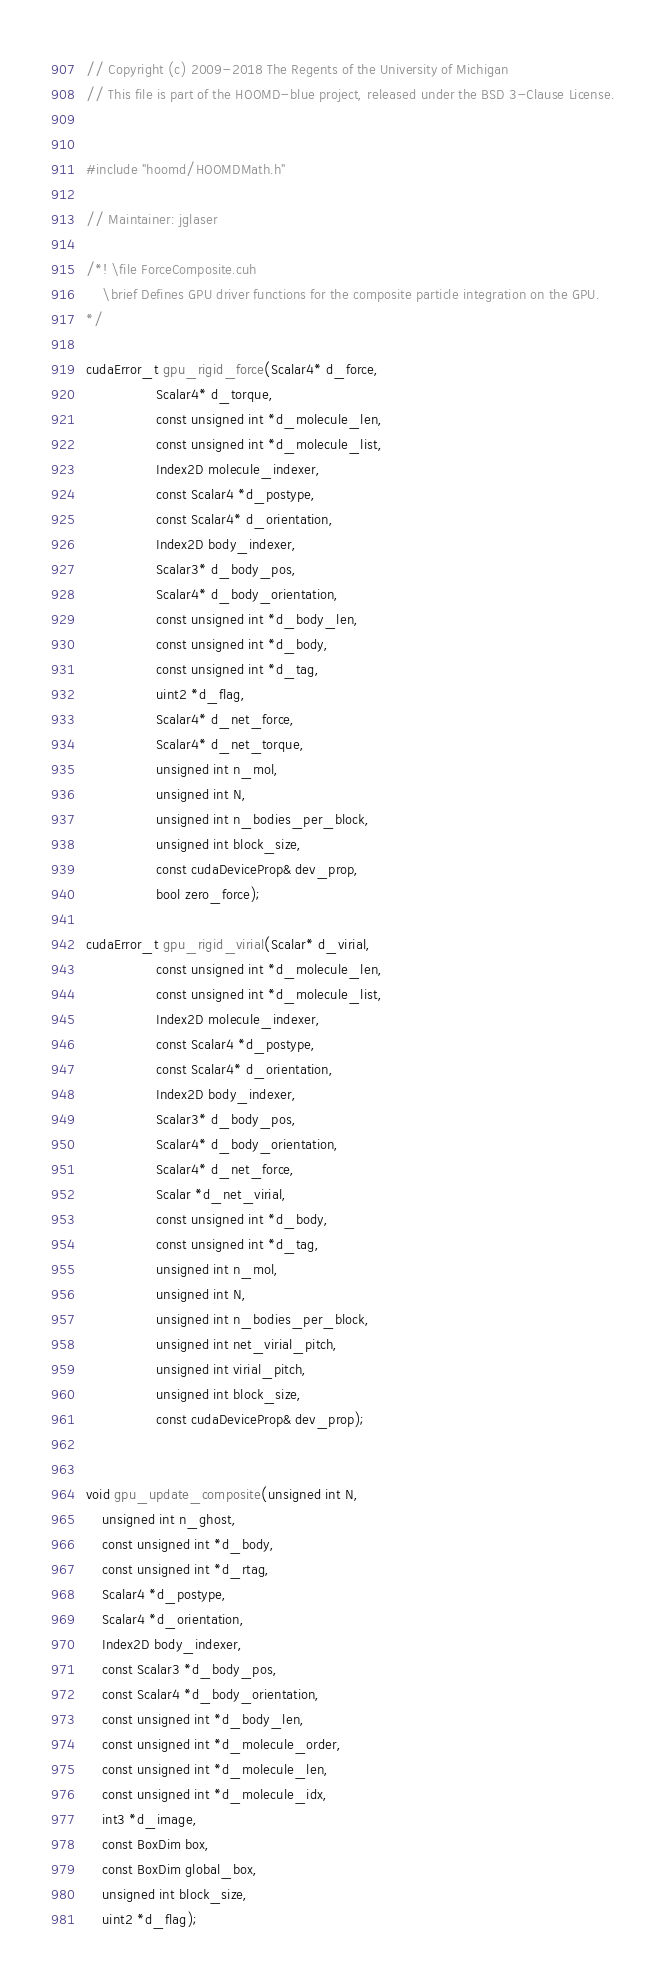Convert code to text. <code><loc_0><loc_0><loc_500><loc_500><_Cuda_>// Copyright (c) 2009-2018 The Regents of the University of Michigan
// This file is part of the HOOMD-blue project, released under the BSD 3-Clause License.


#include "hoomd/HOOMDMath.h"

// Maintainer: jglaser

/*! \file ForceComposite.cuh
    \brief Defines GPU driver functions for the composite particle integration on the GPU.
*/

cudaError_t gpu_rigid_force(Scalar4* d_force,
                 Scalar4* d_torque,
                 const unsigned int *d_molecule_len,
                 const unsigned int *d_molecule_list,
                 Index2D molecule_indexer,
                 const Scalar4 *d_postype,
                 const Scalar4* d_orientation,
                 Index2D body_indexer,
                 Scalar3* d_body_pos,
                 Scalar4* d_body_orientation,
                 const unsigned int *d_body_len,
                 const unsigned int *d_body,
                 const unsigned int *d_tag,
                 uint2 *d_flag,
                 Scalar4* d_net_force,
                 Scalar4* d_net_torque,
                 unsigned int n_mol,
                 unsigned int N,
                 unsigned int n_bodies_per_block,
                 unsigned int block_size,
                 const cudaDeviceProp& dev_prop,
                 bool zero_force);

cudaError_t gpu_rigid_virial(Scalar* d_virial,
                 const unsigned int *d_molecule_len,
                 const unsigned int *d_molecule_list,
                 Index2D molecule_indexer,
                 const Scalar4 *d_postype,
                 const Scalar4* d_orientation,
                 Index2D body_indexer,
                 Scalar3* d_body_pos,
                 Scalar4* d_body_orientation,
                 Scalar4* d_net_force,
                 Scalar *d_net_virial,
                 const unsigned int *d_body,
                 const unsigned int *d_tag,
                 unsigned int n_mol,
                 unsigned int N,
                 unsigned int n_bodies_per_block,
                 unsigned int net_virial_pitch,
                 unsigned int virial_pitch,
                 unsigned int block_size,
                 const cudaDeviceProp& dev_prop);


void gpu_update_composite(unsigned int N,
    unsigned int n_ghost,
    const unsigned int *d_body,
    const unsigned int *d_rtag,
    Scalar4 *d_postype,
    Scalar4 *d_orientation,
    Index2D body_indexer,
    const Scalar3 *d_body_pos,
    const Scalar4 *d_body_orientation,
    const unsigned int *d_body_len,
    const unsigned int *d_molecule_order,
    const unsigned int *d_molecule_len,
    const unsigned int *d_molecule_idx,
    int3 *d_image,
    const BoxDim box,
    const BoxDim global_box,
    unsigned int block_size,
    uint2 *d_flag);
</code> 